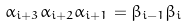Convert formula to latex. <formula><loc_0><loc_0><loc_500><loc_500>\alpha _ { i + 3 } \alpha _ { i + 2 } \alpha _ { i + 1 } = \beta _ { i - 1 } \beta _ { i }</formula> 